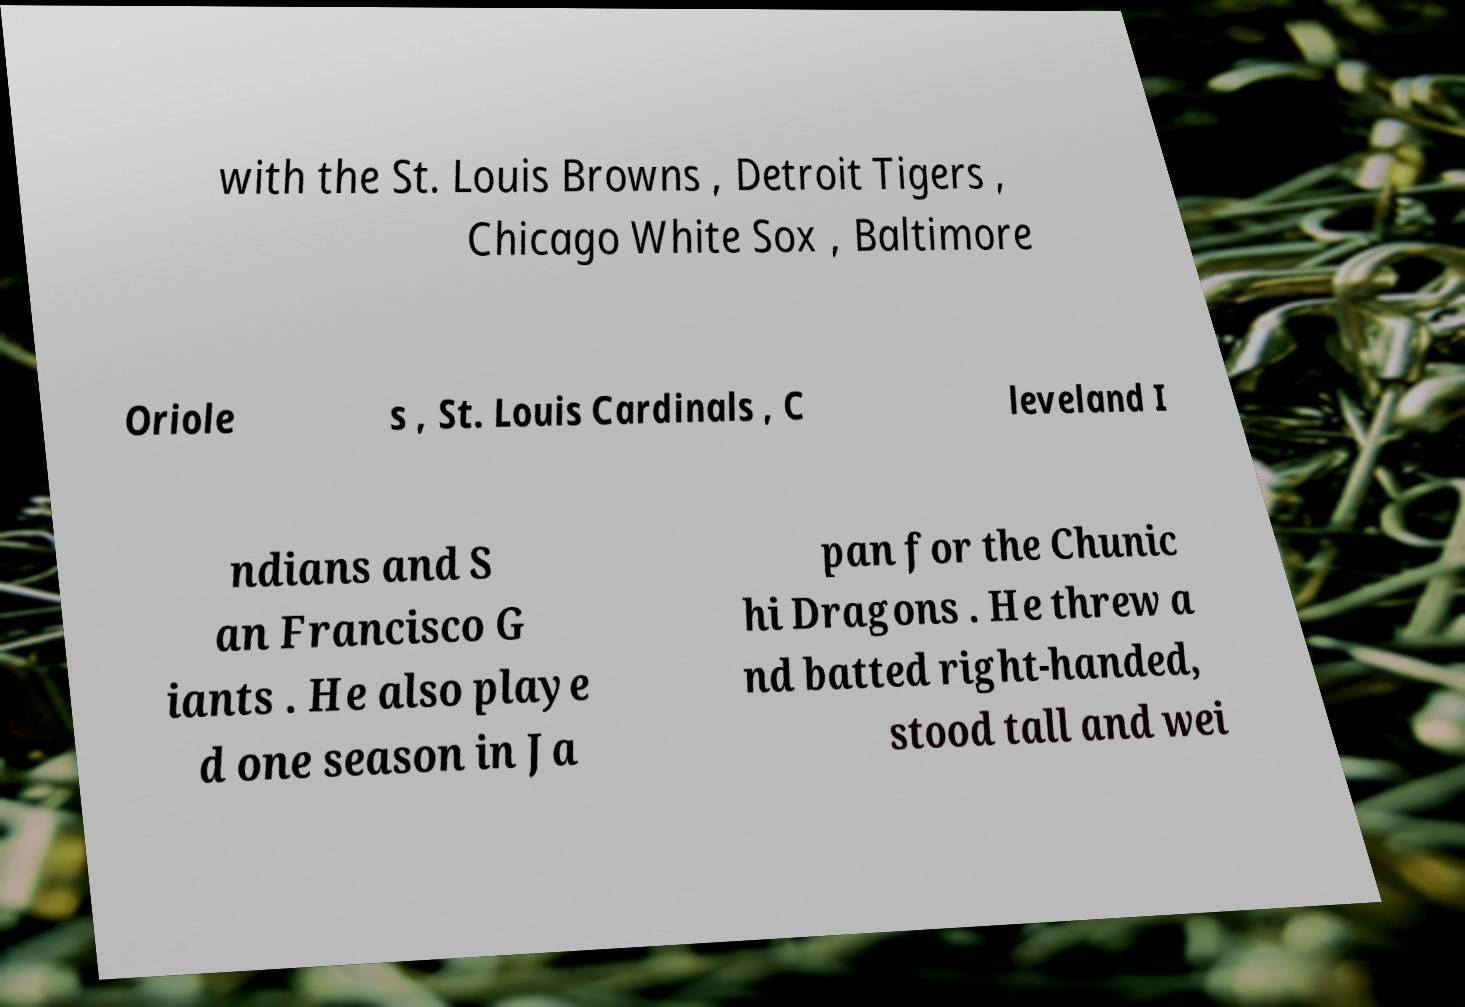There's text embedded in this image that I need extracted. Can you transcribe it verbatim? with the St. Louis Browns , Detroit Tigers , Chicago White Sox , Baltimore Oriole s , St. Louis Cardinals , C leveland I ndians and S an Francisco G iants . He also playe d one season in Ja pan for the Chunic hi Dragons . He threw a nd batted right-handed, stood tall and wei 